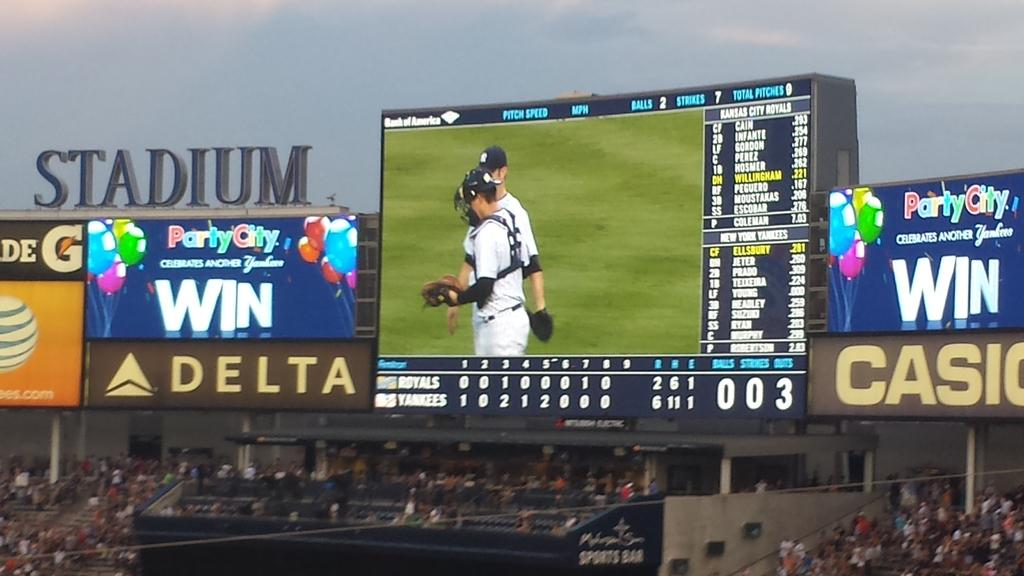<image>
Create a compact narrative representing the image presented. A baseball game is underway at a stadium with ads for Delta and Casio. 